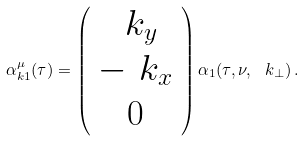<formula> <loc_0><loc_0><loc_500><loc_500>\alpha ^ { \mu } _ { k 1 } ( \tau ) = \left ( \begin{array} { c } \ k _ { y } \\ - \ k _ { x } \\ 0 \end{array} \right ) \alpha _ { 1 } ( \tau , \nu , \ k _ { \perp } ) \, .</formula> 